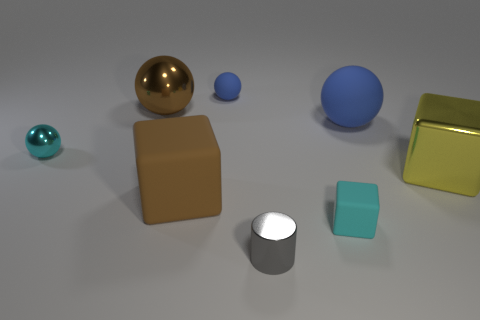What number of blue matte objects are there?
Keep it short and to the point. 2. There is a rubber ball that is the same size as the gray cylinder; what color is it?
Your response must be concise. Blue. Is the material of the tiny cyan object in front of the tiny shiny ball the same as the cyan object that is behind the shiny cube?
Your answer should be compact. No. There is a brown metallic ball behind the gray object that is left of the cyan block; what is its size?
Offer a terse response. Large. What is the material of the blue object behind the brown metal thing?
Offer a very short reply. Rubber. How many objects are either rubber objects that are right of the brown rubber cube or large cubes that are left of the big blue matte thing?
Offer a terse response. 4. There is a cyan object that is the same shape as the large brown shiny object; what is its material?
Your response must be concise. Metal. There is a big cube that is left of the tiny gray metallic cylinder; does it have the same color as the big sphere that is to the left of the big blue matte ball?
Your answer should be very brief. Yes. Is there a gray metal object that has the same size as the cyan metal thing?
Give a very brief answer. Yes. The thing that is both on the right side of the small cyan sphere and to the left of the brown matte thing is made of what material?
Give a very brief answer. Metal. 